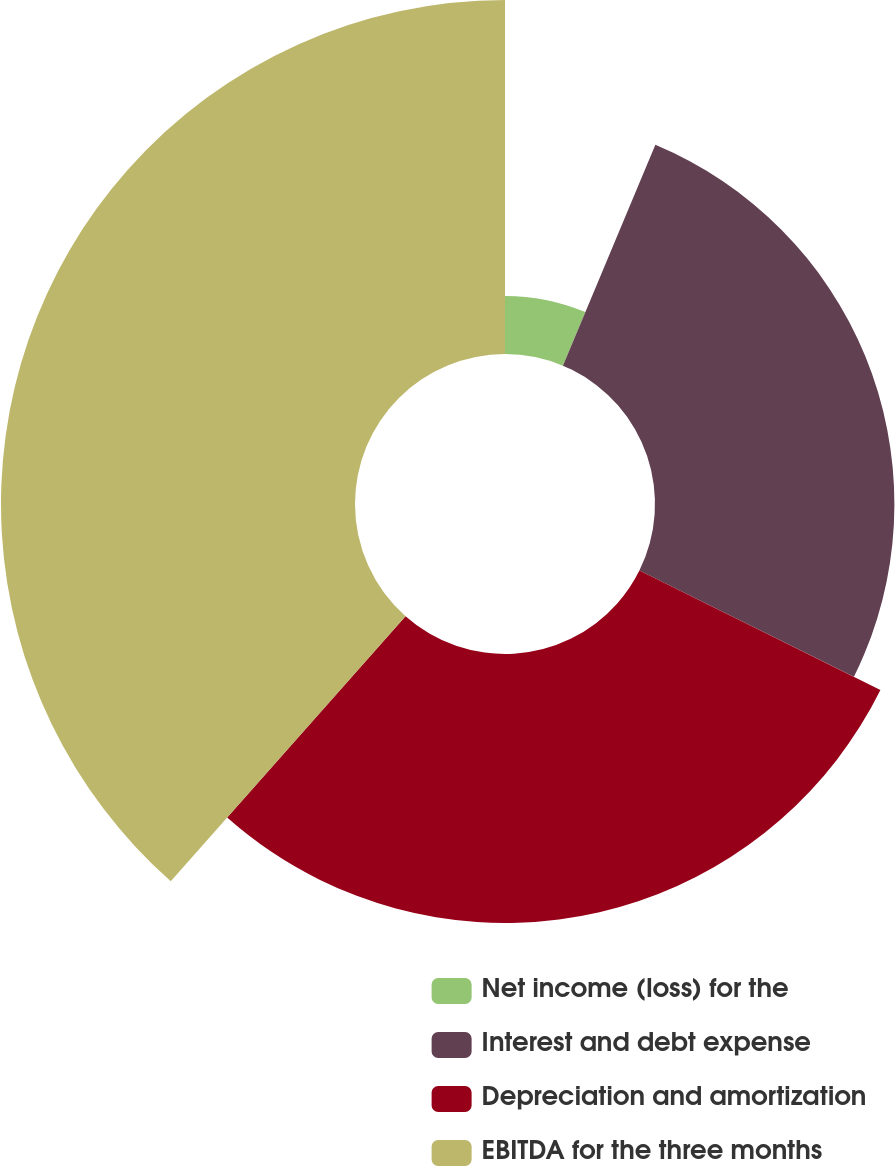Convert chart. <chart><loc_0><loc_0><loc_500><loc_500><pie_chart><fcel>Net income (loss) for the<fcel>Interest and debt expense<fcel>Depreciation and amortization<fcel>EBITDA for the three months<nl><fcel>6.31%<fcel>26.01%<fcel>29.22%<fcel>38.46%<nl></chart> 